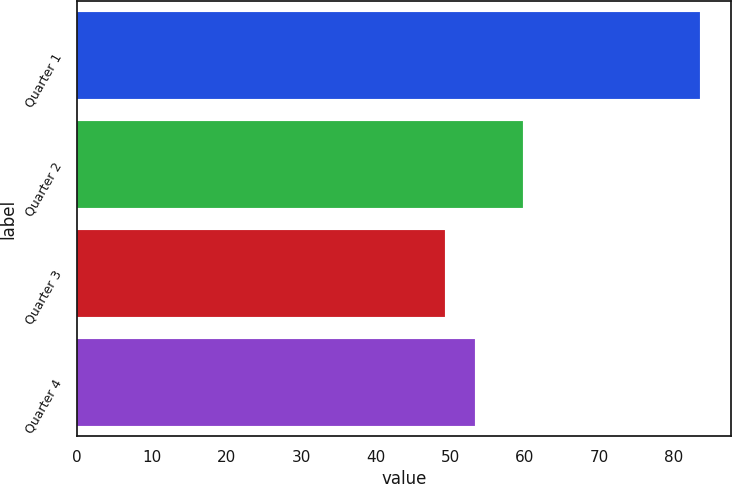Convert chart. <chart><loc_0><loc_0><loc_500><loc_500><bar_chart><fcel>Quarter 1<fcel>Quarter 2<fcel>Quarter 3<fcel>Quarter 4<nl><fcel>83.43<fcel>59.74<fcel>49.24<fcel>53.34<nl></chart> 